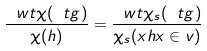<formula> <loc_0><loc_0><loc_500><loc_500>\frac { \ w t \chi ( \ t g ) } { \chi ( h ) } = \frac { \ w t \chi _ { s } ( \ t g ) } { \chi _ { s } ( x h x \in v ) }</formula> 